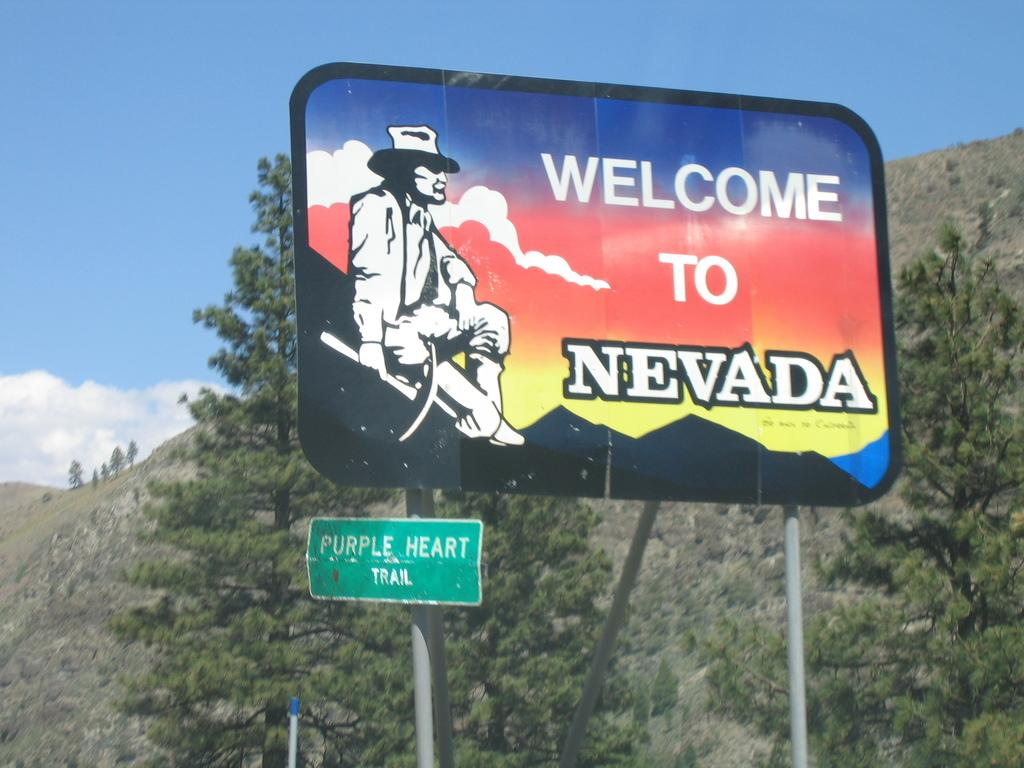<image>
Provide a brief description of the given image. A welcome to Nevada sign is in front of trees and mountains. 